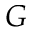Convert formula to latex. <formula><loc_0><loc_0><loc_500><loc_500>G</formula> 